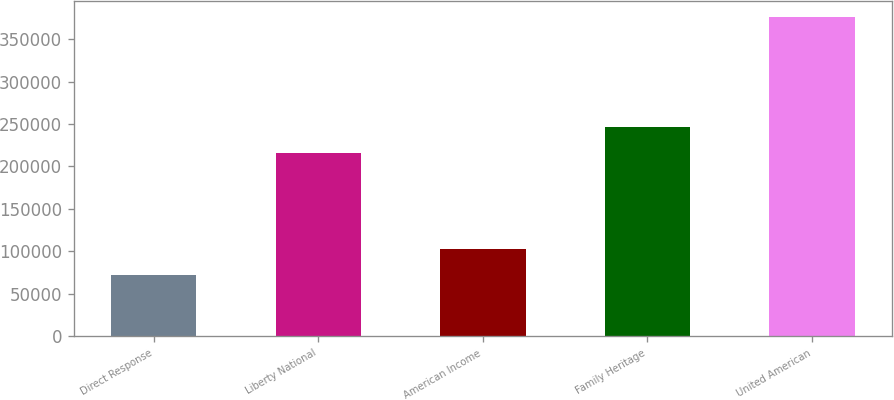<chart> <loc_0><loc_0><loc_500><loc_500><bar_chart><fcel>Direct Response<fcel>Liberty National<fcel>American Income<fcel>Family Heritage<fcel>United American<nl><fcel>72423<fcel>216139<fcel>102811<fcel>246527<fcel>376302<nl></chart> 